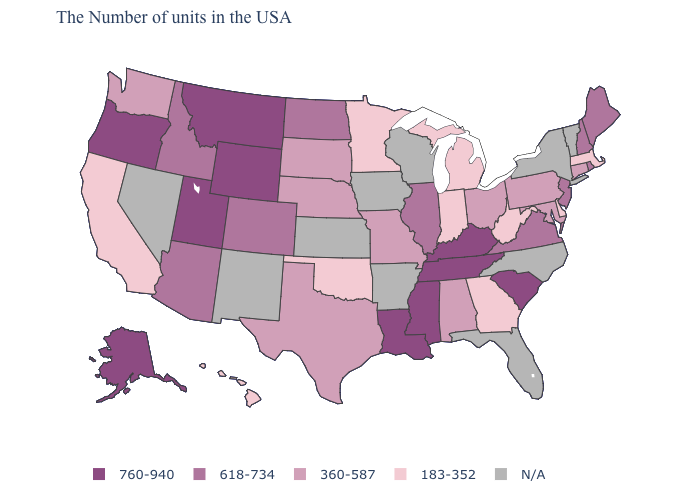Name the states that have a value in the range 183-352?
Quick response, please. Massachusetts, Delaware, West Virginia, Georgia, Michigan, Indiana, Minnesota, Oklahoma, California, Hawaii. What is the highest value in the USA?
Write a very short answer. 760-940. What is the value of Colorado?
Give a very brief answer. 618-734. What is the value of Florida?
Concise answer only. N/A. Name the states that have a value in the range 760-940?
Keep it brief. South Carolina, Kentucky, Tennessee, Mississippi, Louisiana, Wyoming, Utah, Montana, Oregon, Alaska. Which states have the lowest value in the USA?
Quick response, please. Massachusetts, Delaware, West Virginia, Georgia, Michigan, Indiana, Minnesota, Oklahoma, California, Hawaii. Does Georgia have the lowest value in the South?
Be succinct. Yes. What is the highest value in the South ?
Concise answer only. 760-940. Does New Hampshire have the highest value in the Northeast?
Give a very brief answer. Yes. Among the states that border Maryland , does West Virginia have the lowest value?
Give a very brief answer. Yes. Which states have the lowest value in the West?
Keep it brief. California, Hawaii. What is the lowest value in states that border Indiana?
Give a very brief answer. 183-352. What is the value of Indiana?
Give a very brief answer. 183-352. Name the states that have a value in the range N/A?
Keep it brief. Vermont, New York, North Carolina, Florida, Wisconsin, Arkansas, Iowa, Kansas, New Mexico, Nevada. What is the value of California?
Quick response, please. 183-352. 